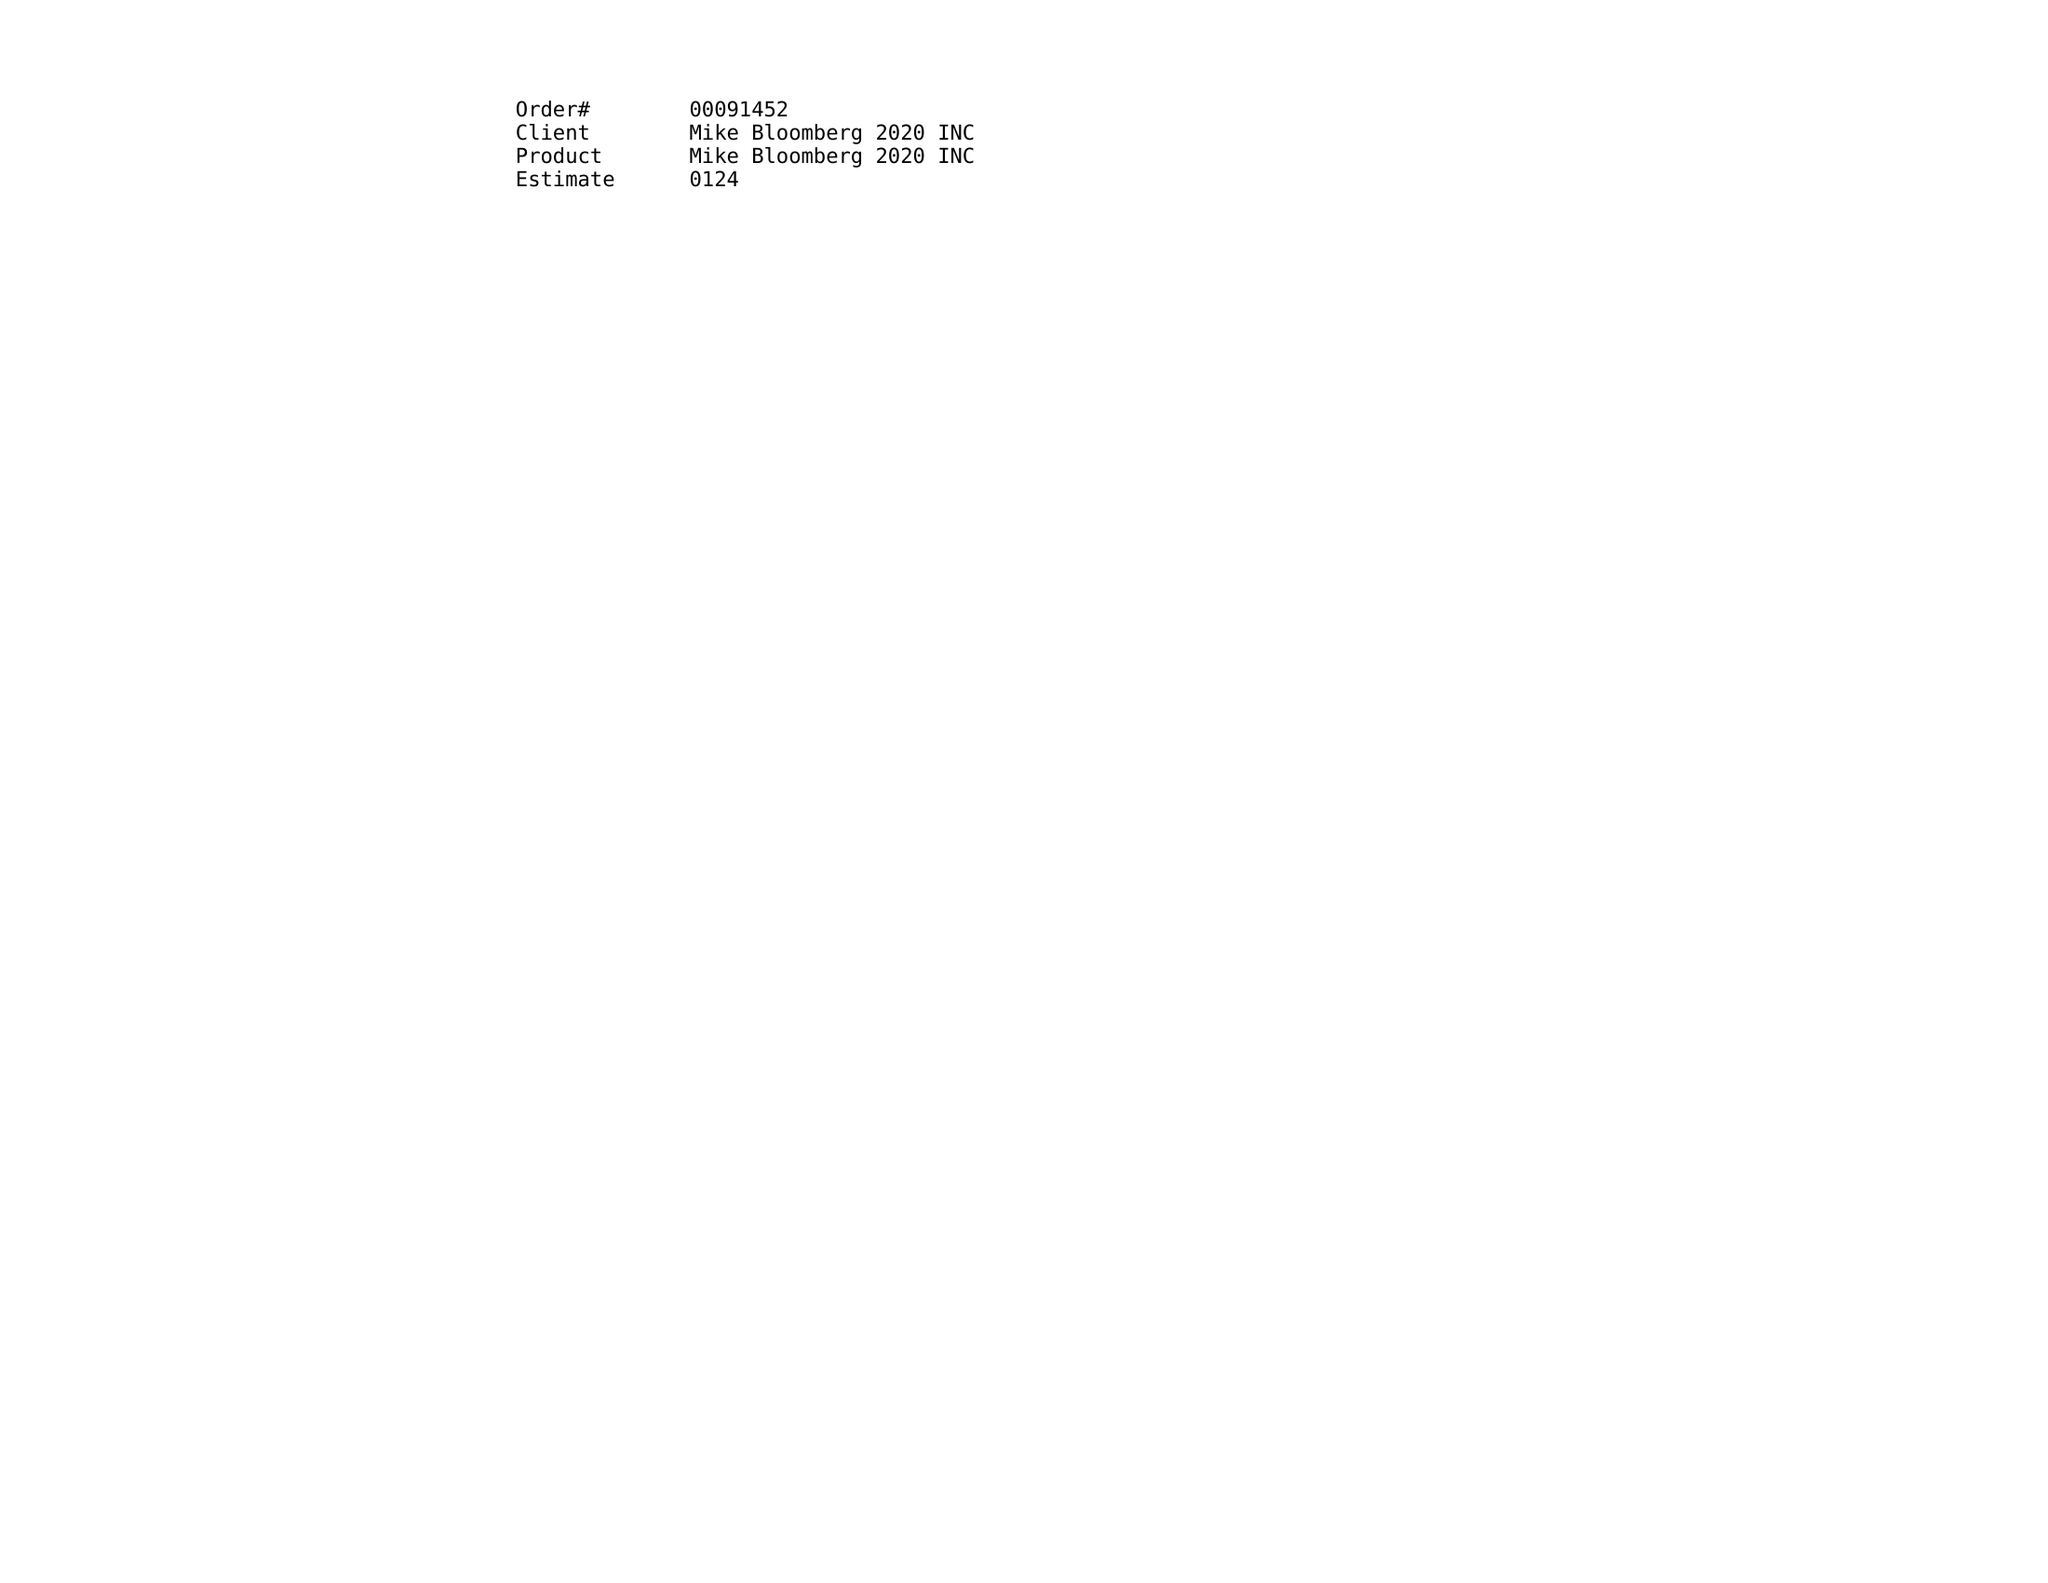What is the value for the gross_amount?
Answer the question using a single word or phrase. 6845.00 